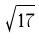<formula> <loc_0><loc_0><loc_500><loc_500>\sqrt { 1 7 }</formula> 